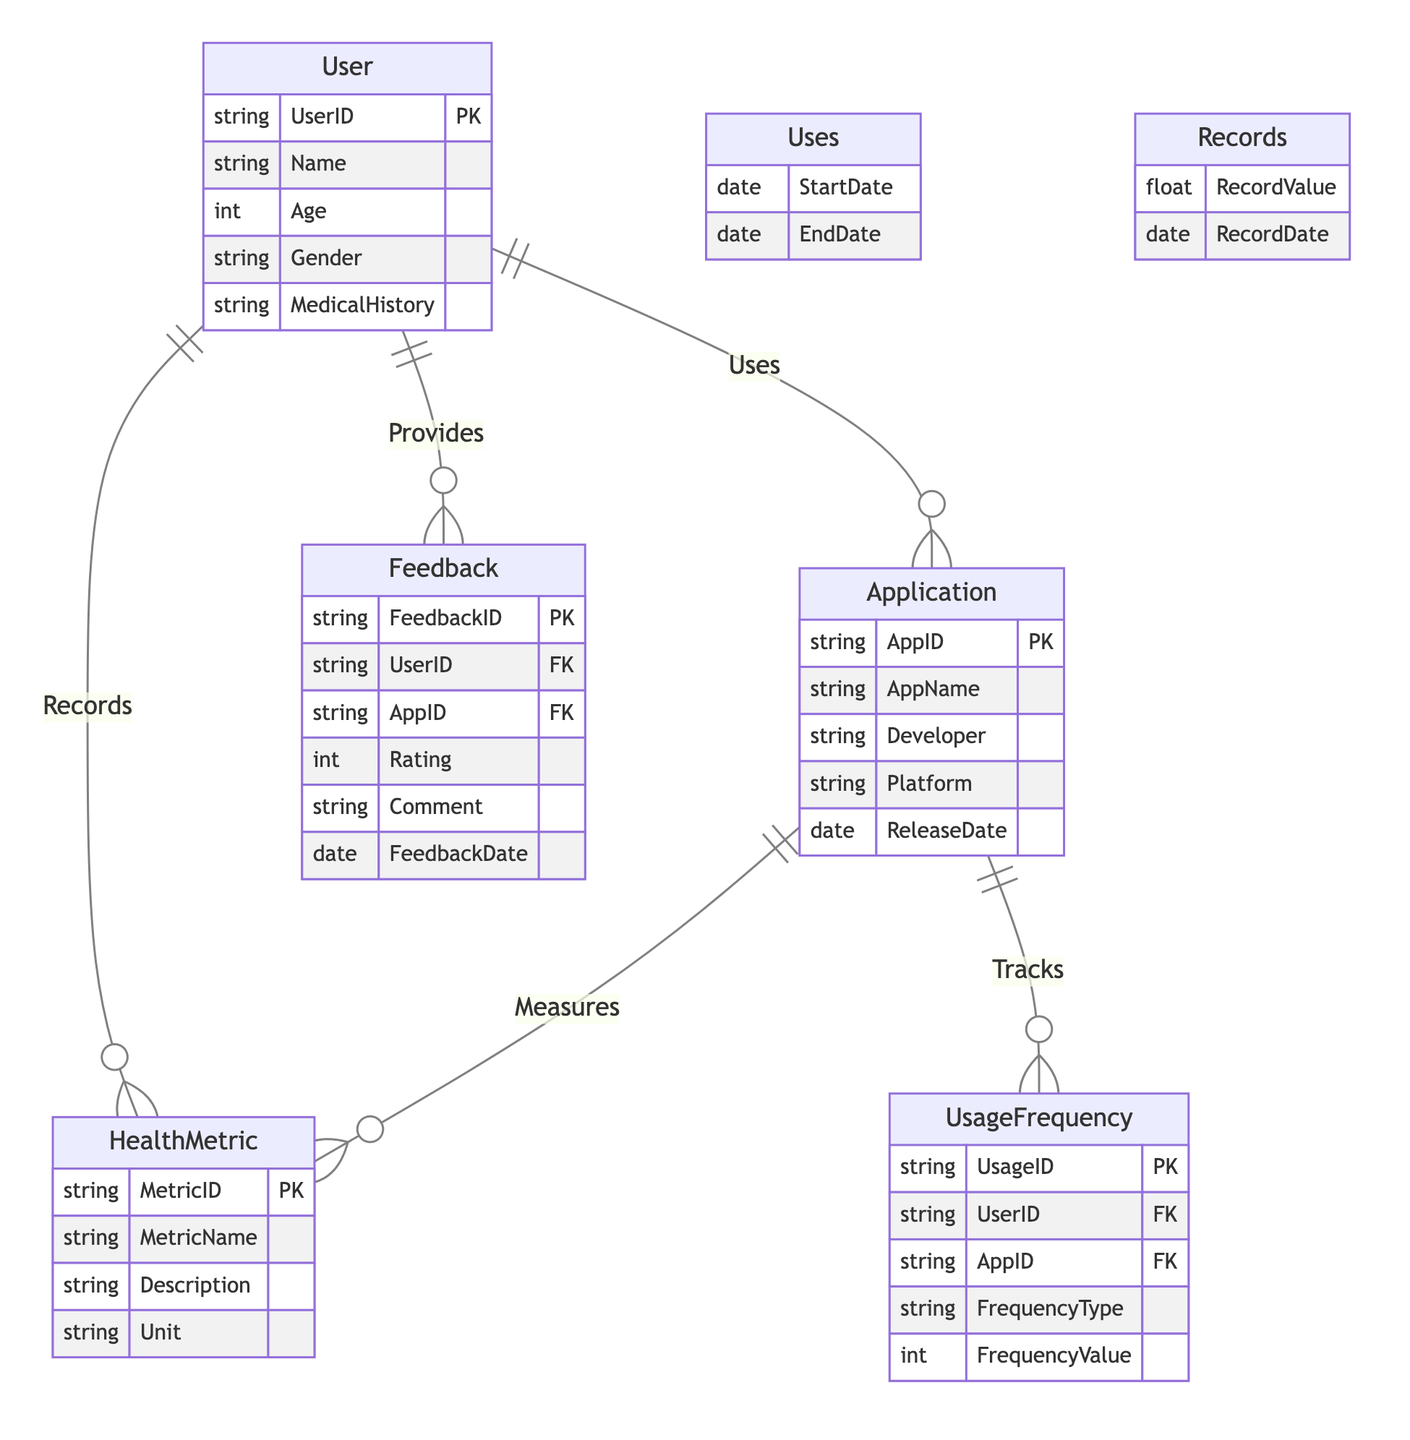What are the attributes of the User entity? The User entity has five attributes: UserID, Name, Age, Gender, and MedicalHistory. This information is represented directly under the User node in the diagram.
Answer: UserID, Name, Age, Gender, MedicalHistory How many relationships are there between the entities? The diagram contains five relationships: Uses, Measures, Records, Provides, and Tracks. Each relationship connects different entities, which can be counted visually from the relationship lines in the diagram.
Answer: 5 What is the primary key of the Application entity? The primary key for the Application entity is AppID, which is marked as PK in the diagram to signify its uniqueness in the application records.
Answer: AppID Which entity has a relationship labeled "Tracks"? The entity that has a relationship labeled "Tracks" is Application. This is shown in the diagram where the Application entity is connected to UsageFrequency through the Tracks relationship.
Answer: Application What is the frequency type attribute in the UsageFrequency entity? The UsageFrequency entity includes an attribute named FrequencyType, which describes the way usage is categorized (e.g., daily, weekly). This attribute is explicitly outlined under the UsageFrequency node in the diagram.
Answer: FrequencyType How would you describe the relationship between User and HealthMetric? The relationship between User and HealthMetric is described as Records. This indicates that a User can record various health metrics over time, connecting the two entities logically in the context of the application.
Answer: Records What attributes are associated with the Feedback entity? The Feedback entity has six attributes: FeedbackID, UserID, AppID, Rating, Comment, and FeedbackDate. Each attribute stores specific information related to user feedback on applications, as indicated in the diagram.
Answer: FeedbackID, UserID, AppID, Rating, Comment, FeedbackDate Which entity connects to both HealthMetric and Application? The User entity connects to both HealthMetric and Application, showing that a User can record HealthMetrics and use Applications, making it a central point in the diagram's logic.
Answer: User What does the Measures relationship represent? The Measures relationship represents the association between Application and HealthMetric, indicating that an application measures various health metrics, as detailed in the diagram.
Answer: Application and HealthMetric 